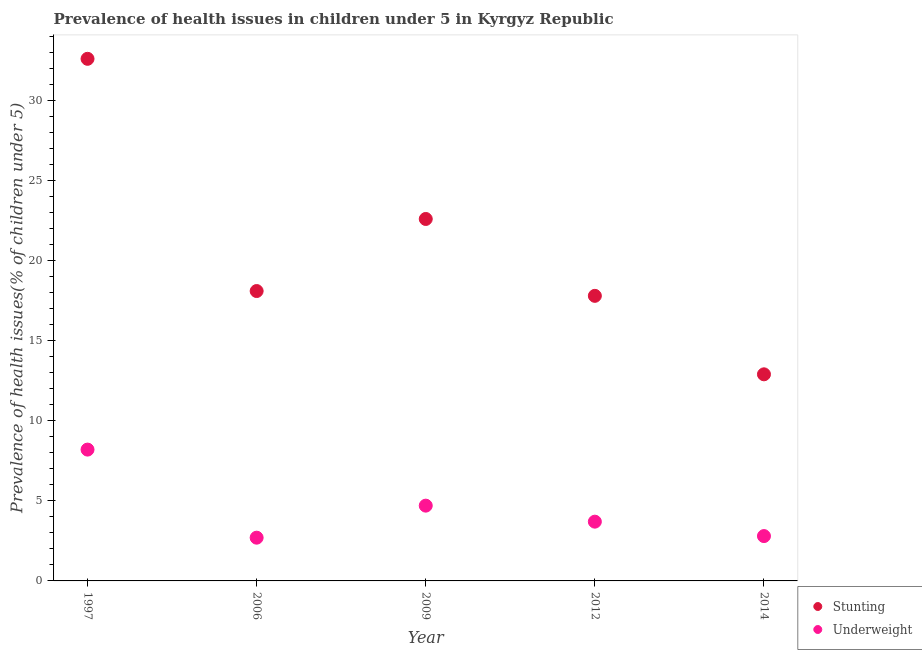Is the number of dotlines equal to the number of legend labels?
Make the answer very short. Yes. What is the percentage of stunted children in 2009?
Make the answer very short. 22.6. Across all years, what is the maximum percentage of underweight children?
Provide a succinct answer. 8.2. Across all years, what is the minimum percentage of underweight children?
Make the answer very short. 2.7. In which year was the percentage of underweight children minimum?
Ensure brevity in your answer.  2006. What is the total percentage of stunted children in the graph?
Offer a terse response. 104. What is the difference between the percentage of stunted children in 1997 and that in 2009?
Offer a very short reply. 10. What is the difference between the percentage of underweight children in 2006 and the percentage of stunted children in 2014?
Your answer should be very brief. -10.2. What is the average percentage of stunted children per year?
Your answer should be compact. 20.8. In the year 1997, what is the difference between the percentage of stunted children and percentage of underweight children?
Give a very brief answer. 24.4. In how many years, is the percentage of underweight children greater than 1 %?
Give a very brief answer. 5. What is the ratio of the percentage of underweight children in 2006 to that in 2009?
Your answer should be very brief. 0.57. Is the percentage of underweight children in 2006 less than that in 2014?
Make the answer very short. Yes. What is the difference between the highest and the second highest percentage of stunted children?
Make the answer very short. 10. What is the difference between the highest and the lowest percentage of underweight children?
Keep it short and to the point. 5.5. In how many years, is the percentage of stunted children greater than the average percentage of stunted children taken over all years?
Your answer should be very brief. 2. Does the percentage of stunted children monotonically increase over the years?
Offer a very short reply. No. Is the percentage of stunted children strictly greater than the percentage of underweight children over the years?
Ensure brevity in your answer.  Yes. Is the percentage of stunted children strictly less than the percentage of underweight children over the years?
Your answer should be compact. No. How many dotlines are there?
Provide a succinct answer. 2. How many years are there in the graph?
Offer a terse response. 5. Does the graph contain grids?
Your answer should be very brief. No. How many legend labels are there?
Your answer should be compact. 2. What is the title of the graph?
Your response must be concise. Prevalence of health issues in children under 5 in Kyrgyz Republic. What is the label or title of the X-axis?
Give a very brief answer. Year. What is the label or title of the Y-axis?
Ensure brevity in your answer.  Prevalence of health issues(% of children under 5). What is the Prevalence of health issues(% of children under 5) of Stunting in 1997?
Make the answer very short. 32.6. What is the Prevalence of health issues(% of children under 5) in Underweight in 1997?
Keep it short and to the point. 8.2. What is the Prevalence of health issues(% of children under 5) in Stunting in 2006?
Give a very brief answer. 18.1. What is the Prevalence of health issues(% of children under 5) of Underweight in 2006?
Provide a short and direct response. 2.7. What is the Prevalence of health issues(% of children under 5) in Stunting in 2009?
Keep it short and to the point. 22.6. What is the Prevalence of health issues(% of children under 5) of Underweight in 2009?
Ensure brevity in your answer.  4.7. What is the Prevalence of health issues(% of children under 5) in Stunting in 2012?
Ensure brevity in your answer.  17.8. What is the Prevalence of health issues(% of children under 5) in Underweight in 2012?
Your answer should be very brief. 3.7. What is the Prevalence of health issues(% of children under 5) of Stunting in 2014?
Offer a terse response. 12.9. What is the Prevalence of health issues(% of children under 5) in Underweight in 2014?
Your answer should be very brief. 2.8. Across all years, what is the maximum Prevalence of health issues(% of children under 5) of Stunting?
Ensure brevity in your answer.  32.6. Across all years, what is the maximum Prevalence of health issues(% of children under 5) of Underweight?
Your answer should be very brief. 8.2. Across all years, what is the minimum Prevalence of health issues(% of children under 5) in Stunting?
Make the answer very short. 12.9. Across all years, what is the minimum Prevalence of health issues(% of children under 5) of Underweight?
Keep it short and to the point. 2.7. What is the total Prevalence of health issues(% of children under 5) of Stunting in the graph?
Provide a short and direct response. 104. What is the total Prevalence of health issues(% of children under 5) of Underweight in the graph?
Ensure brevity in your answer.  22.1. What is the difference between the Prevalence of health issues(% of children under 5) of Stunting in 1997 and that in 2006?
Provide a succinct answer. 14.5. What is the difference between the Prevalence of health issues(% of children under 5) of Underweight in 1997 and that in 2006?
Make the answer very short. 5.5. What is the difference between the Prevalence of health issues(% of children under 5) in Underweight in 1997 and that in 2012?
Keep it short and to the point. 4.5. What is the difference between the Prevalence of health issues(% of children under 5) in Underweight in 1997 and that in 2014?
Give a very brief answer. 5.4. What is the difference between the Prevalence of health issues(% of children under 5) of Stunting in 2006 and that in 2009?
Your response must be concise. -4.5. What is the difference between the Prevalence of health issues(% of children under 5) in Stunting in 2006 and that in 2012?
Provide a short and direct response. 0.3. What is the difference between the Prevalence of health issues(% of children under 5) of Underweight in 2006 and that in 2012?
Provide a succinct answer. -1. What is the difference between the Prevalence of health issues(% of children under 5) of Stunting in 2009 and that in 2014?
Offer a very short reply. 9.7. What is the difference between the Prevalence of health issues(% of children under 5) of Underweight in 2009 and that in 2014?
Your answer should be compact. 1.9. What is the difference between the Prevalence of health issues(% of children under 5) in Underweight in 2012 and that in 2014?
Ensure brevity in your answer.  0.9. What is the difference between the Prevalence of health issues(% of children under 5) of Stunting in 1997 and the Prevalence of health issues(% of children under 5) of Underweight in 2006?
Your answer should be compact. 29.9. What is the difference between the Prevalence of health issues(% of children under 5) in Stunting in 1997 and the Prevalence of health issues(% of children under 5) in Underweight in 2009?
Provide a succinct answer. 27.9. What is the difference between the Prevalence of health issues(% of children under 5) of Stunting in 1997 and the Prevalence of health issues(% of children under 5) of Underweight in 2012?
Give a very brief answer. 28.9. What is the difference between the Prevalence of health issues(% of children under 5) of Stunting in 1997 and the Prevalence of health issues(% of children under 5) of Underweight in 2014?
Give a very brief answer. 29.8. What is the difference between the Prevalence of health issues(% of children under 5) of Stunting in 2006 and the Prevalence of health issues(% of children under 5) of Underweight in 2012?
Keep it short and to the point. 14.4. What is the difference between the Prevalence of health issues(% of children under 5) in Stunting in 2006 and the Prevalence of health issues(% of children under 5) in Underweight in 2014?
Offer a very short reply. 15.3. What is the difference between the Prevalence of health issues(% of children under 5) of Stunting in 2009 and the Prevalence of health issues(% of children under 5) of Underweight in 2014?
Give a very brief answer. 19.8. What is the difference between the Prevalence of health issues(% of children under 5) of Stunting in 2012 and the Prevalence of health issues(% of children under 5) of Underweight in 2014?
Your answer should be very brief. 15. What is the average Prevalence of health issues(% of children under 5) of Stunting per year?
Offer a terse response. 20.8. What is the average Prevalence of health issues(% of children under 5) in Underweight per year?
Provide a succinct answer. 4.42. In the year 1997, what is the difference between the Prevalence of health issues(% of children under 5) of Stunting and Prevalence of health issues(% of children under 5) of Underweight?
Keep it short and to the point. 24.4. In the year 2006, what is the difference between the Prevalence of health issues(% of children under 5) in Stunting and Prevalence of health issues(% of children under 5) in Underweight?
Ensure brevity in your answer.  15.4. In the year 2014, what is the difference between the Prevalence of health issues(% of children under 5) of Stunting and Prevalence of health issues(% of children under 5) of Underweight?
Offer a terse response. 10.1. What is the ratio of the Prevalence of health issues(% of children under 5) of Stunting in 1997 to that in 2006?
Give a very brief answer. 1.8. What is the ratio of the Prevalence of health issues(% of children under 5) of Underweight in 1997 to that in 2006?
Ensure brevity in your answer.  3.04. What is the ratio of the Prevalence of health issues(% of children under 5) of Stunting in 1997 to that in 2009?
Give a very brief answer. 1.44. What is the ratio of the Prevalence of health issues(% of children under 5) of Underweight in 1997 to that in 2009?
Keep it short and to the point. 1.74. What is the ratio of the Prevalence of health issues(% of children under 5) in Stunting in 1997 to that in 2012?
Provide a short and direct response. 1.83. What is the ratio of the Prevalence of health issues(% of children under 5) in Underweight in 1997 to that in 2012?
Provide a short and direct response. 2.22. What is the ratio of the Prevalence of health issues(% of children under 5) of Stunting in 1997 to that in 2014?
Provide a short and direct response. 2.53. What is the ratio of the Prevalence of health issues(% of children under 5) in Underweight in 1997 to that in 2014?
Your answer should be very brief. 2.93. What is the ratio of the Prevalence of health issues(% of children under 5) in Stunting in 2006 to that in 2009?
Your answer should be compact. 0.8. What is the ratio of the Prevalence of health issues(% of children under 5) in Underweight in 2006 to that in 2009?
Your response must be concise. 0.57. What is the ratio of the Prevalence of health issues(% of children under 5) of Stunting in 2006 to that in 2012?
Provide a succinct answer. 1.02. What is the ratio of the Prevalence of health issues(% of children under 5) in Underweight in 2006 to that in 2012?
Ensure brevity in your answer.  0.73. What is the ratio of the Prevalence of health issues(% of children under 5) of Stunting in 2006 to that in 2014?
Give a very brief answer. 1.4. What is the ratio of the Prevalence of health issues(% of children under 5) in Stunting in 2009 to that in 2012?
Provide a succinct answer. 1.27. What is the ratio of the Prevalence of health issues(% of children under 5) of Underweight in 2009 to that in 2012?
Give a very brief answer. 1.27. What is the ratio of the Prevalence of health issues(% of children under 5) in Stunting in 2009 to that in 2014?
Offer a terse response. 1.75. What is the ratio of the Prevalence of health issues(% of children under 5) in Underweight in 2009 to that in 2014?
Keep it short and to the point. 1.68. What is the ratio of the Prevalence of health issues(% of children under 5) in Stunting in 2012 to that in 2014?
Your answer should be compact. 1.38. What is the ratio of the Prevalence of health issues(% of children under 5) in Underweight in 2012 to that in 2014?
Offer a very short reply. 1.32. What is the difference between the highest and the second highest Prevalence of health issues(% of children under 5) of Stunting?
Your answer should be very brief. 10. What is the difference between the highest and the second highest Prevalence of health issues(% of children under 5) of Underweight?
Offer a terse response. 3.5. What is the difference between the highest and the lowest Prevalence of health issues(% of children under 5) in Stunting?
Your answer should be very brief. 19.7. 